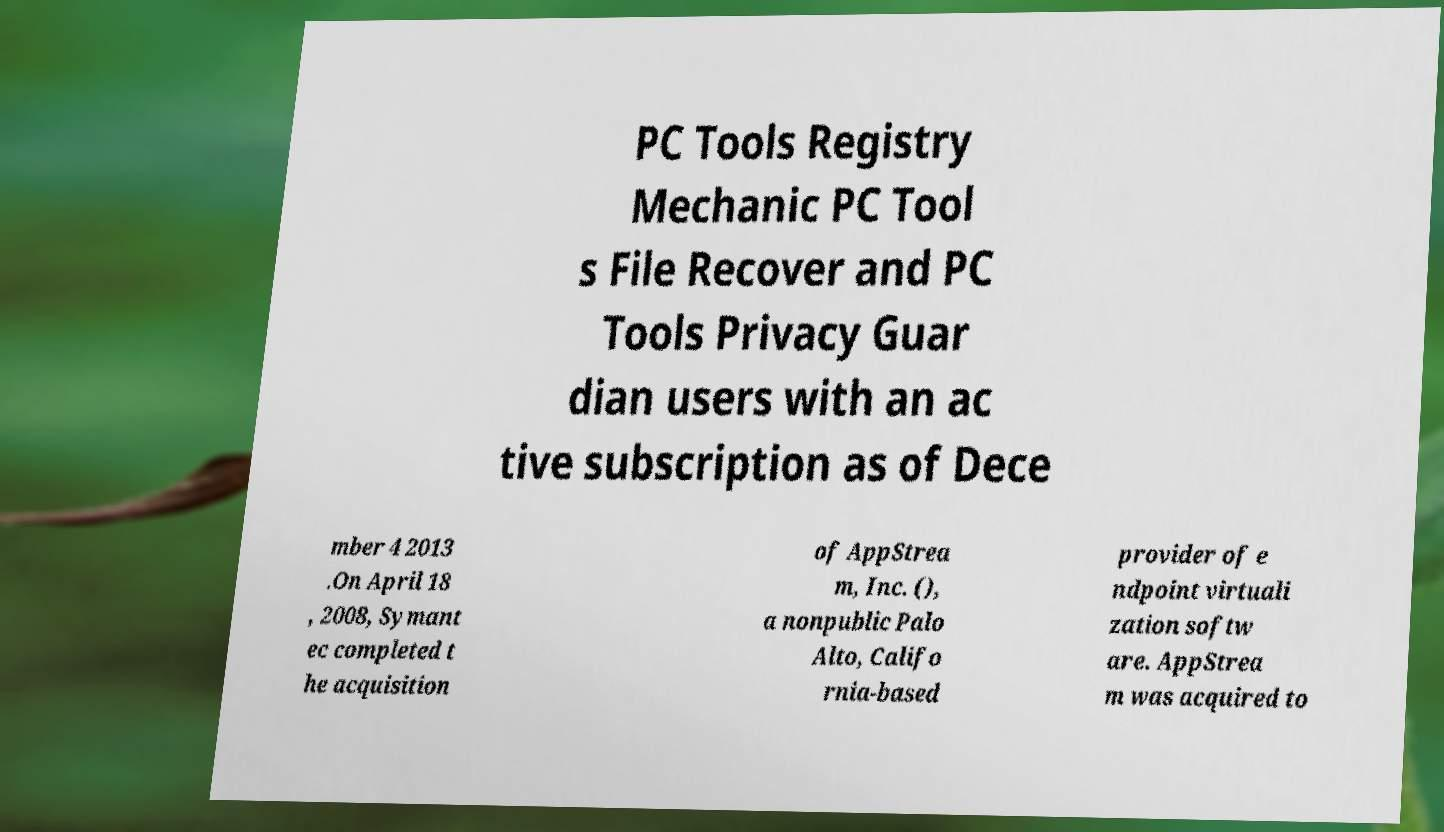Can you accurately transcribe the text from the provided image for me? PC Tools Registry Mechanic PC Tool s File Recover and PC Tools Privacy Guar dian users with an ac tive subscription as of Dece mber 4 2013 .On April 18 , 2008, Symant ec completed t he acquisition of AppStrea m, Inc. (), a nonpublic Palo Alto, Califo rnia-based provider of e ndpoint virtuali zation softw are. AppStrea m was acquired to 